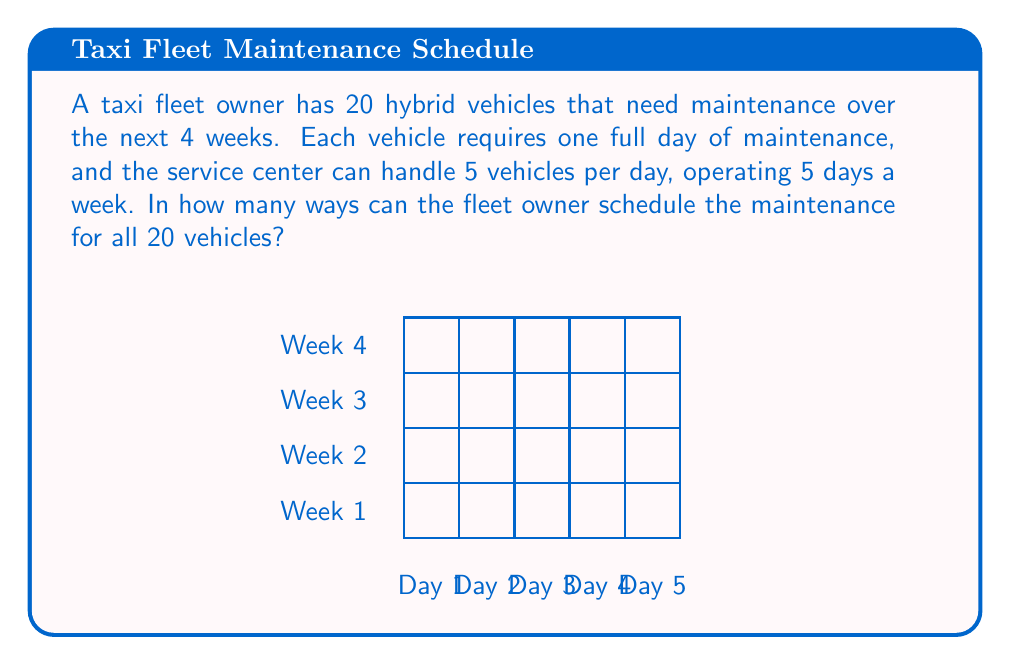What is the answer to this math problem? Let's approach this step-by-step:

1) First, we need to calculate the total number of available maintenance slots:
   - 4 weeks × 5 days per week × 5 vehicles per day = 100 slots

2) We need to choose 20 slots out of these 100 for our vehicles. This is a combination problem.

3) The formula for combinations is:

   $$C(n,r) = \frac{n!}{r!(n-r)!}$$

   where $n$ is the total number of items to choose from, and $r$ is the number of items being chosen.

4) In our case, $n = 100$ and $r = 20$. So we're calculating $C(100,20)$:

   $$C(100,20) = \frac{100!}{20!(100-20)!} = \frac{100!}{20!80!}$$

5) This can be simplified to:

   $$\frac{100 \times 99 \times 98 \times ... \times 81}{20 \times 19 \times 18 \times ... \times 1}$$

6) Calculating this gives us a very large number:

   $$C(100,20) = 535,983,370,403,809,682,970,732,273,600$$

This represents the number of ways to schedule the maintenance for all 20 vehicles over the 4-week period.
Answer: $535,983,370,403,809,682,970,732,273,600$ 